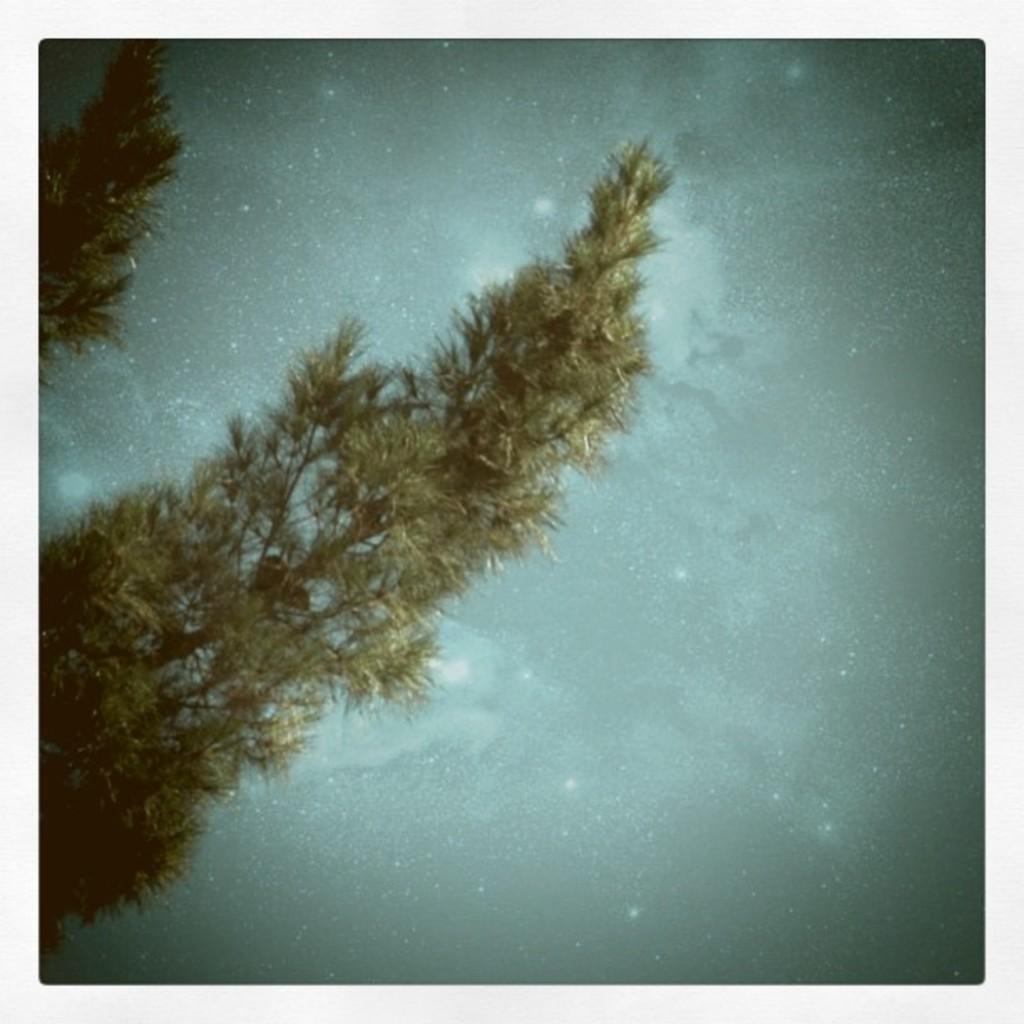Please provide a concise description of this image. This image consists of two trees. One is in the top left corner, another one is in the middle. 